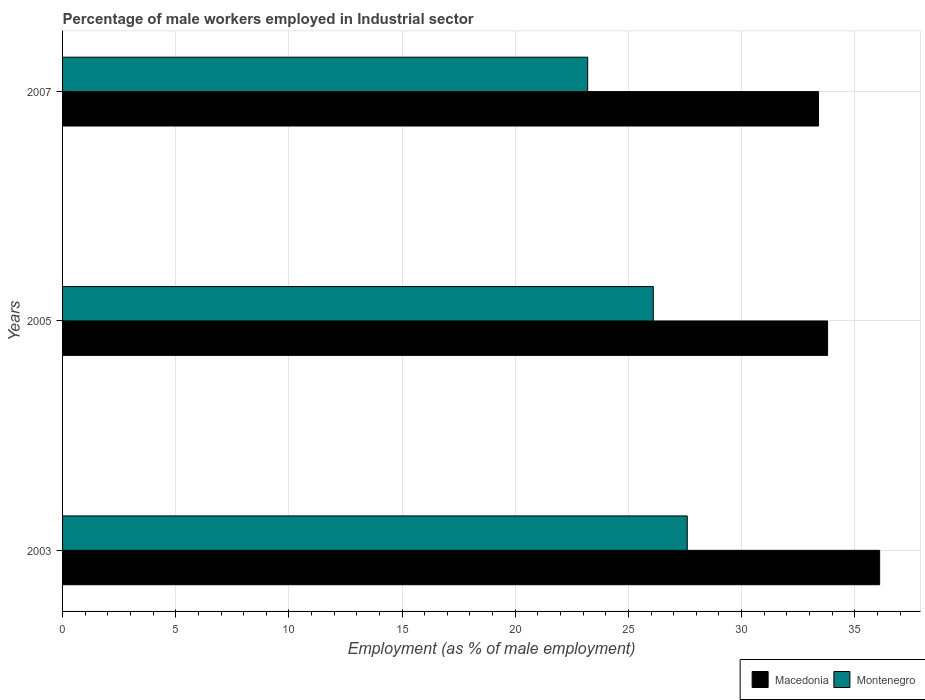How many different coloured bars are there?
Ensure brevity in your answer.  2. How many bars are there on the 1st tick from the top?
Offer a very short reply. 2. What is the label of the 3rd group of bars from the top?
Keep it short and to the point. 2003. What is the percentage of male workers employed in Industrial sector in Montenegro in 2007?
Provide a succinct answer. 23.2. Across all years, what is the maximum percentage of male workers employed in Industrial sector in Macedonia?
Offer a terse response. 36.1. Across all years, what is the minimum percentage of male workers employed in Industrial sector in Macedonia?
Offer a very short reply. 33.4. What is the total percentage of male workers employed in Industrial sector in Macedonia in the graph?
Give a very brief answer. 103.3. What is the difference between the percentage of male workers employed in Industrial sector in Montenegro in 2003 and that in 2007?
Make the answer very short. 4.4. What is the difference between the percentage of male workers employed in Industrial sector in Macedonia in 2005 and the percentage of male workers employed in Industrial sector in Montenegro in 2003?
Make the answer very short. 6.2. What is the average percentage of male workers employed in Industrial sector in Macedonia per year?
Your answer should be compact. 34.43. In the year 2005, what is the difference between the percentage of male workers employed in Industrial sector in Montenegro and percentage of male workers employed in Industrial sector in Macedonia?
Offer a very short reply. -7.7. In how many years, is the percentage of male workers employed in Industrial sector in Macedonia greater than 4 %?
Your response must be concise. 3. What is the ratio of the percentage of male workers employed in Industrial sector in Montenegro in 2003 to that in 2007?
Keep it short and to the point. 1.19. Is the percentage of male workers employed in Industrial sector in Montenegro in 2005 less than that in 2007?
Offer a very short reply. No. Is the difference between the percentage of male workers employed in Industrial sector in Montenegro in 2003 and 2007 greater than the difference between the percentage of male workers employed in Industrial sector in Macedonia in 2003 and 2007?
Offer a very short reply. Yes. What is the difference between the highest and the lowest percentage of male workers employed in Industrial sector in Montenegro?
Give a very brief answer. 4.4. In how many years, is the percentage of male workers employed in Industrial sector in Montenegro greater than the average percentage of male workers employed in Industrial sector in Montenegro taken over all years?
Offer a terse response. 2. What does the 2nd bar from the top in 2007 represents?
Your answer should be very brief. Macedonia. What does the 1st bar from the bottom in 2003 represents?
Keep it short and to the point. Macedonia. How many bars are there?
Provide a short and direct response. 6. Are all the bars in the graph horizontal?
Your answer should be compact. Yes. How many years are there in the graph?
Make the answer very short. 3. What is the difference between two consecutive major ticks on the X-axis?
Your answer should be very brief. 5. Where does the legend appear in the graph?
Provide a succinct answer. Bottom right. How many legend labels are there?
Offer a very short reply. 2. What is the title of the graph?
Offer a very short reply. Percentage of male workers employed in Industrial sector. Does "Greenland" appear as one of the legend labels in the graph?
Make the answer very short. No. What is the label or title of the X-axis?
Offer a terse response. Employment (as % of male employment). What is the label or title of the Y-axis?
Provide a succinct answer. Years. What is the Employment (as % of male employment) of Macedonia in 2003?
Keep it short and to the point. 36.1. What is the Employment (as % of male employment) of Montenegro in 2003?
Your answer should be very brief. 27.6. What is the Employment (as % of male employment) in Macedonia in 2005?
Offer a terse response. 33.8. What is the Employment (as % of male employment) in Montenegro in 2005?
Offer a terse response. 26.1. What is the Employment (as % of male employment) in Macedonia in 2007?
Your answer should be compact. 33.4. What is the Employment (as % of male employment) in Montenegro in 2007?
Your response must be concise. 23.2. Across all years, what is the maximum Employment (as % of male employment) in Macedonia?
Provide a short and direct response. 36.1. Across all years, what is the maximum Employment (as % of male employment) of Montenegro?
Provide a succinct answer. 27.6. Across all years, what is the minimum Employment (as % of male employment) in Macedonia?
Give a very brief answer. 33.4. Across all years, what is the minimum Employment (as % of male employment) in Montenegro?
Ensure brevity in your answer.  23.2. What is the total Employment (as % of male employment) of Macedonia in the graph?
Give a very brief answer. 103.3. What is the total Employment (as % of male employment) of Montenegro in the graph?
Ensure brevity in your answer.  76.9. What is the difference between the Employment (as % of male employment) of Macedonia in 2003 and that in 2005?
Offer a very short reply. 2.3. What is the difference between the Employment (as % of male employment) in Montenegro in 2005 and that in 2007?
Your response must be concise. 2.9. What is the difference between the Employment (as % of male employment) of Macedonia in 2003 and the Employment (as % of male employment) of Montenegro in 2005?
Provide a short and direct response. 10. What is the difference between the Employment (as % of male employment) of Macedonia in 2003 and the Employment (as % of male employment) of Montenegro in 2007?
Your answer should be very brief. 12.9. What is the difference between the Employment (as % of male employment) of Macedonia in 2005 and the Employment (as % of male employment) of Montenegro in 2007?
Provide a succinct answer. 10.6. What is the average Employment (as % of male employment) in Macedonia per year?
Your answer should be very brief. 34.43. What is the average Employment (as % of male employment) in Montenegro per year?
Make the answer very short. 25.63. In the year 2007, what is the difference between the Employment (as % of male employment) of Macedonia and Employment (as % of male employment) of Montenegro?
Give a very brief answer. 10.2. What is the ratio of the Employment (as % of male employment) of Macedonia in 2003 to that in 2005?
Your answer should be very brief. 1.07. What is the ratio of the Employment (as % of male employment) in Montenegro in 2003 to that in 2005?
Keep it short and to the point. 1.06. What is the ratio of the Employment (as % of male employment) in Macedonia in 2003 to that in 2007?
Give a very brief answer. 1.08. What is the ratio of the Employment (as % of male employment) of Montenegro in 2003 to that in 2007?
Offer a terse response. 1.19. What is the ratio of the Employment (as % of male employment) in Montenegro in 2005 to that in 2007?
Offer a terse response. 1.12. What is the difference between the highest and the second highest Employment (as % of male employment) of Macedonia?
Your response must be concise. 2.3. What is the difference between the highest and the lowest Employment (as % of male employment) of Macedonia?
Your response must be concise. 2.7. 